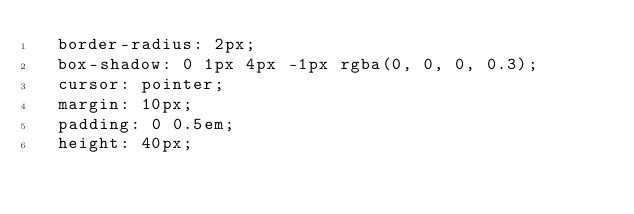Convert code to text. <code><loc_0><loc_0><loc_500><loc_500><_CSS_>  border-radius: 2px;
  box-shadow: 0 1px 4px -1px rgba(0, 0, 0, 0.3);
  cursor: pointer;
  margin: 10px;
  padding: 0 0.5em;
  height: 40px;</code> 